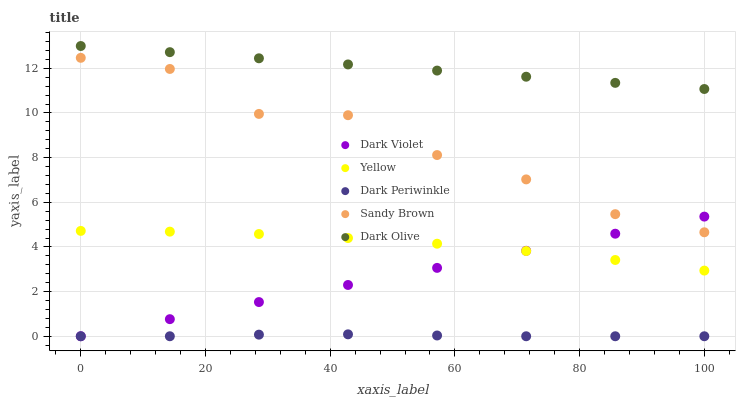Does Dark Periwinkle have the minimum area under the curve?
Answer yes or no. Yes. Does Dark Olive have the maximum area under the curve?
Answer yes or no. Yes. Does Sandy Brown have the minimum area under the curve?
Answer yes or no. No. Does Sandy Brown have the maximum area under the curve?
Answer yes or no. No. Is Dark Violet the smoothest?
Answer yes or no. Yes. Is Sandy Brown the roughest?
Answer yes or no. Yes. Is Yellow the smoothest?
Answer yes or no. No. Is Yellow the roughest?
Answer yes or no. No. Does Dark Violet have the lowest value?
Answer yes or no. Yes. Does Sandy Brown have the lowest value?
Answer yes or no. No. Does Dark Olive have the highest value?
Answer yes or no. Yes. Does Sandy Brown have the highest value?
Answer yes or no. No. Is Dark Periwinkle less than Yellow?
Answer yes or no. Yes. Is Dark Olive greater than Dark Violet?
Answer yes or no. Yes. Does Dark Violet intersect Yellow?
Answer yes or no. Yes. Is Dark Violet less than Yellow?
Answer yes or no. No. Is Dark Violet greater than Yellow?
Answer yes or no. No. Does Dark Periwinkle intersect Yellow?
Answer yes or no. No. 